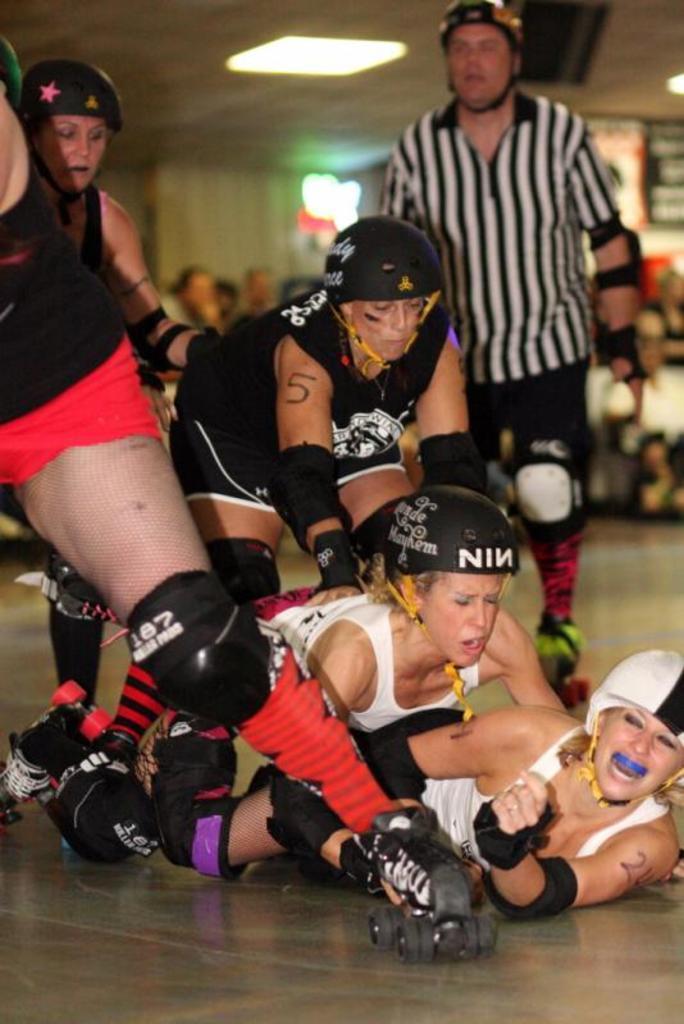Could you give a brief overview of what you see in this image? In this image we can see few people wearing helmets, knee pads and elbow pads. They are wearing skating shoes. In the background there are lights. And it is looking blur. 